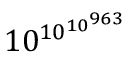<formula> <loc_0><loc_0><loc_500><loc_500>1 0 ^ { \, 1 0 ^ { 1 0 ^ { 9 6 3 } } }</formula> 